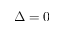<formula> <loc_0><loc_0><loc_500><loc_500>\Delta = 0</formula> 